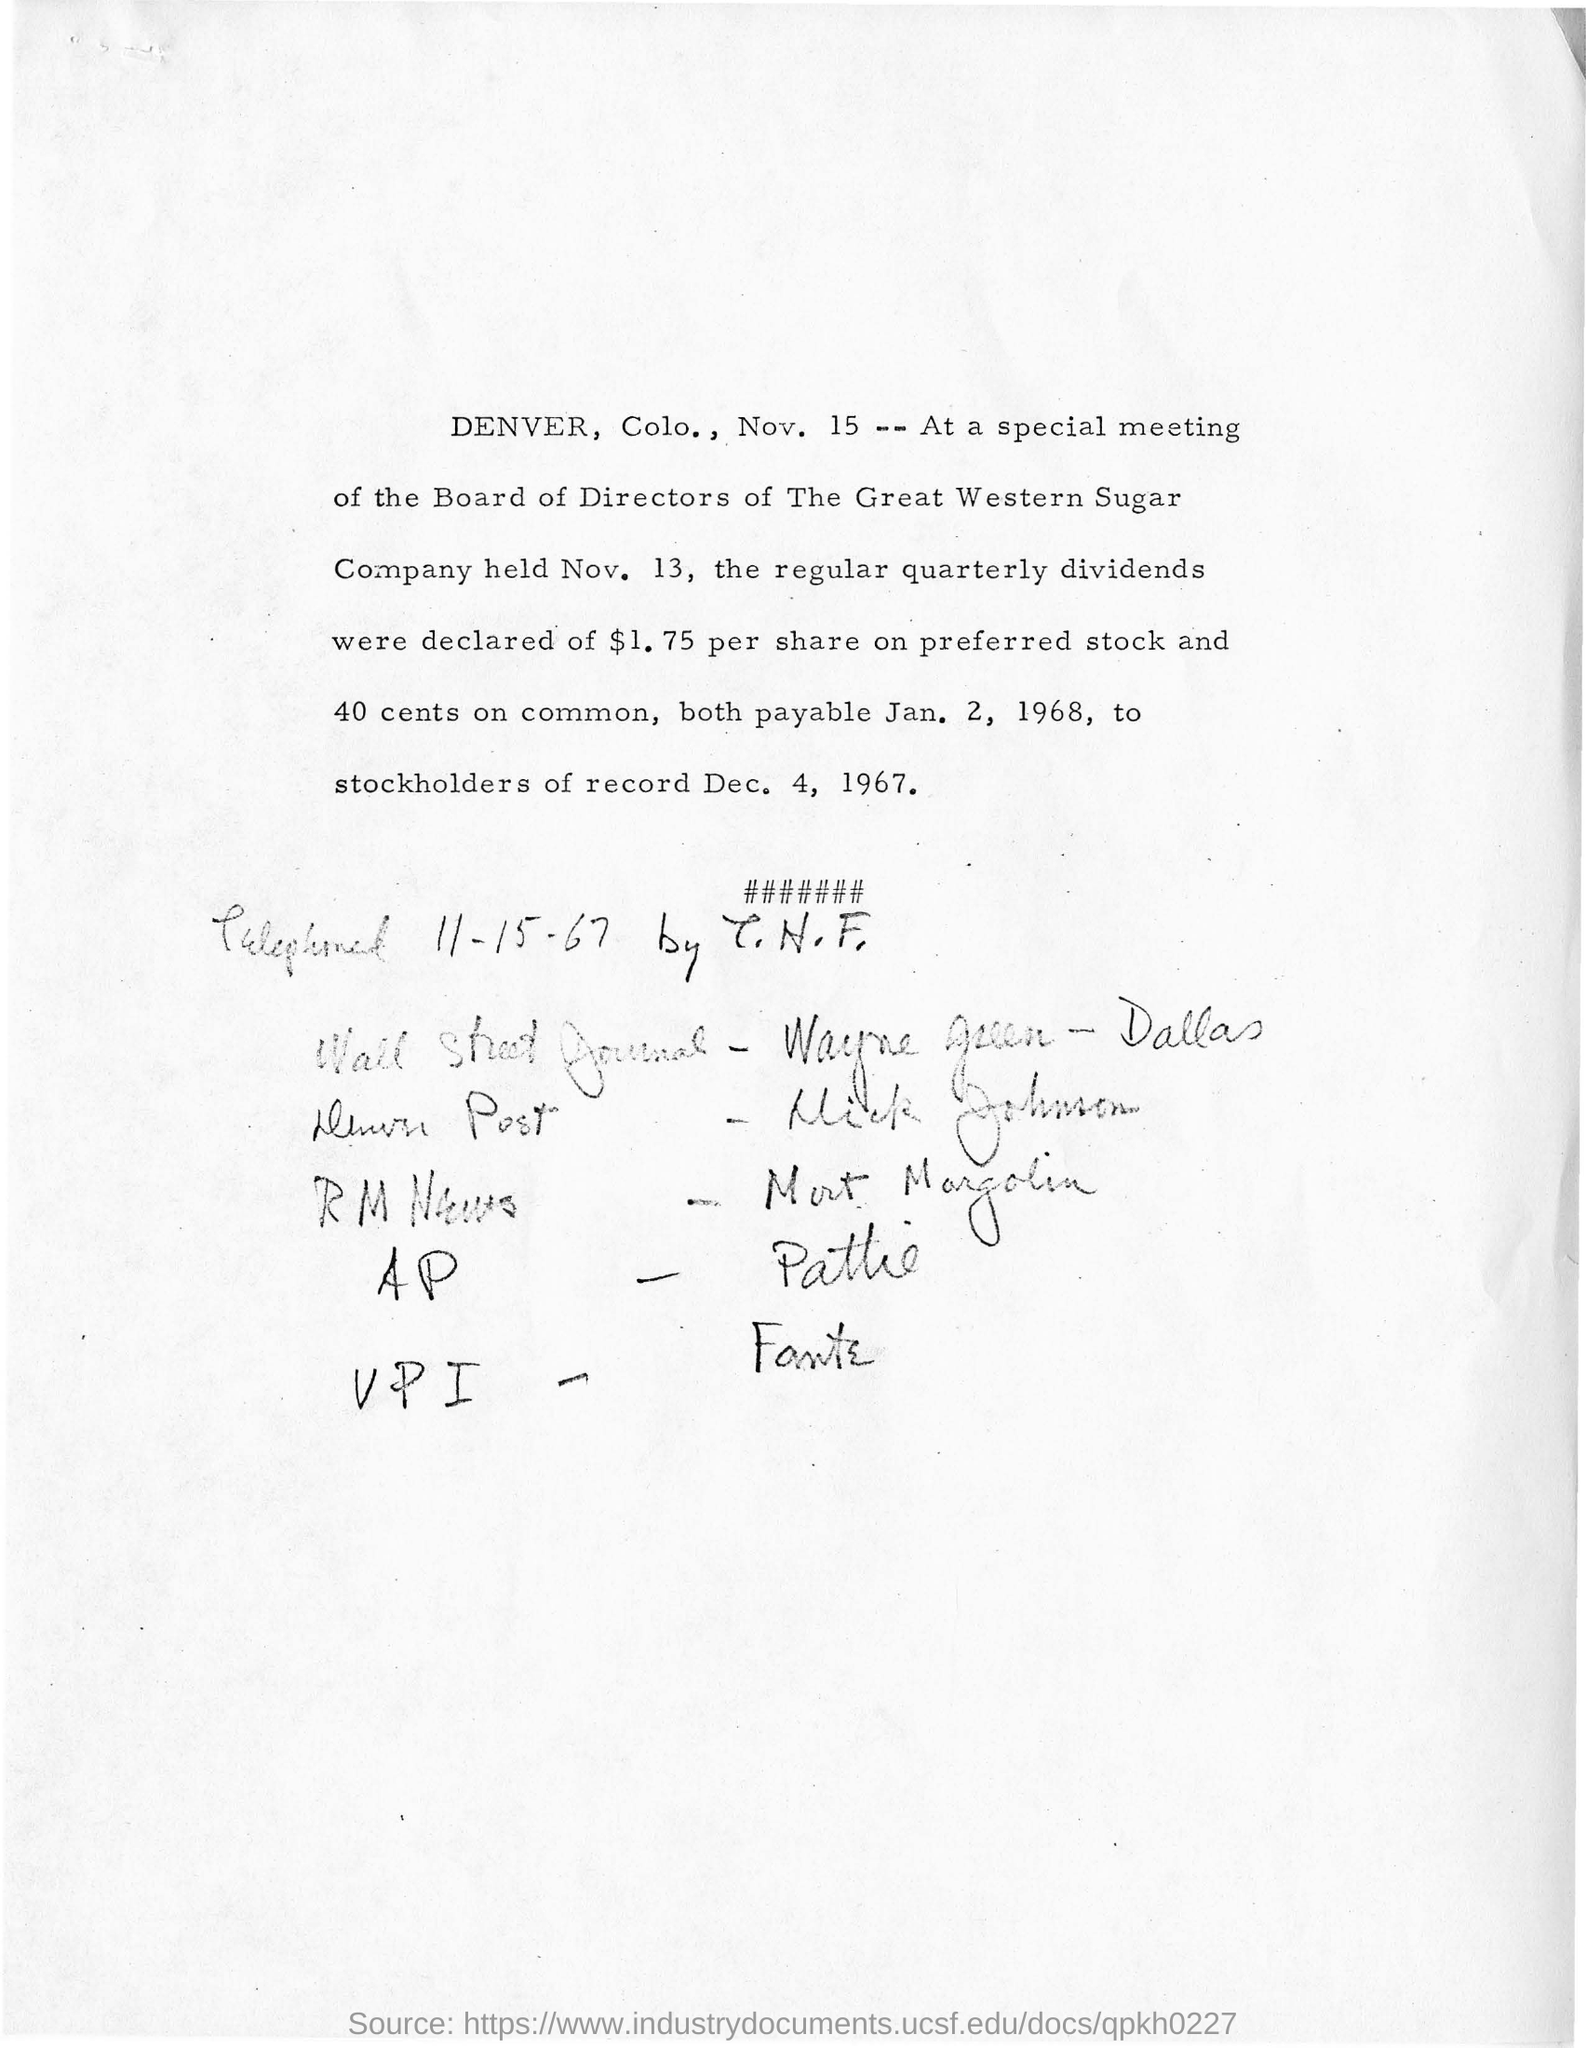Highlight a few significant elements in this photo. Preferred stockholders are to be paid $1.75 per share in dollars, as declared. The Board of Directors of the great Western Sugar Company belong to a particular company. The special meeting will be held on November 13th. The special meeting is held in Denver, Colorado. 